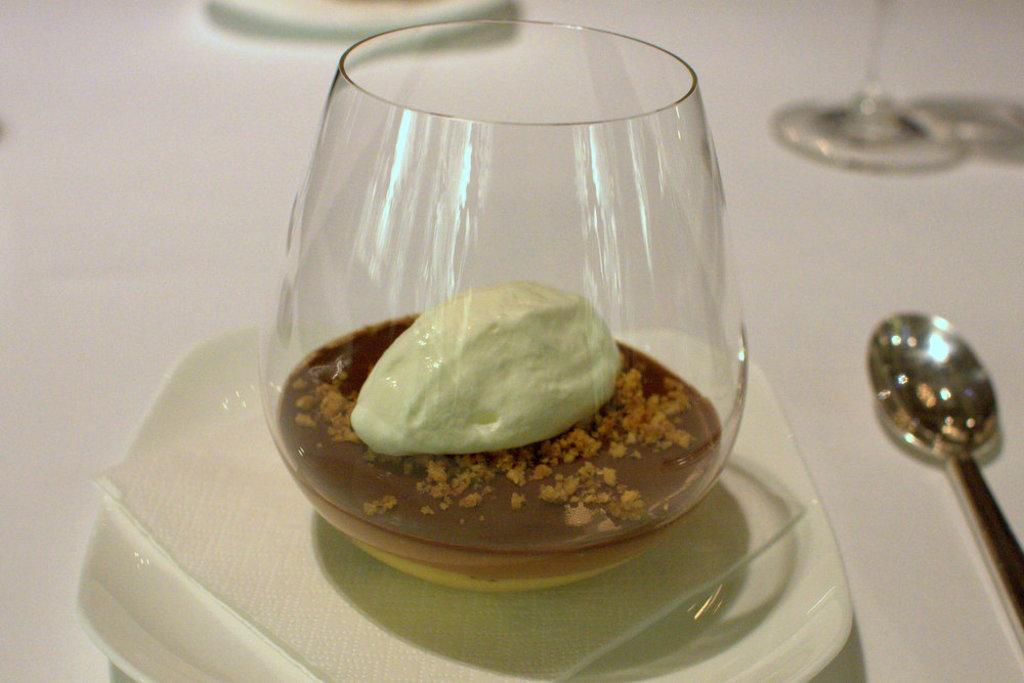What is the primary color of the surface in the image? The primary color of the surface in the image is white. What is placed on the white surface? There is a plate and a spoon on the white surface. What is on the plate? There is a glass with a food item on the plate. What type of body treatment is being performed in the image? There is no body treatment being performed in the image; it features a white surface with a plate, a spoon, and a glass with a food item. 